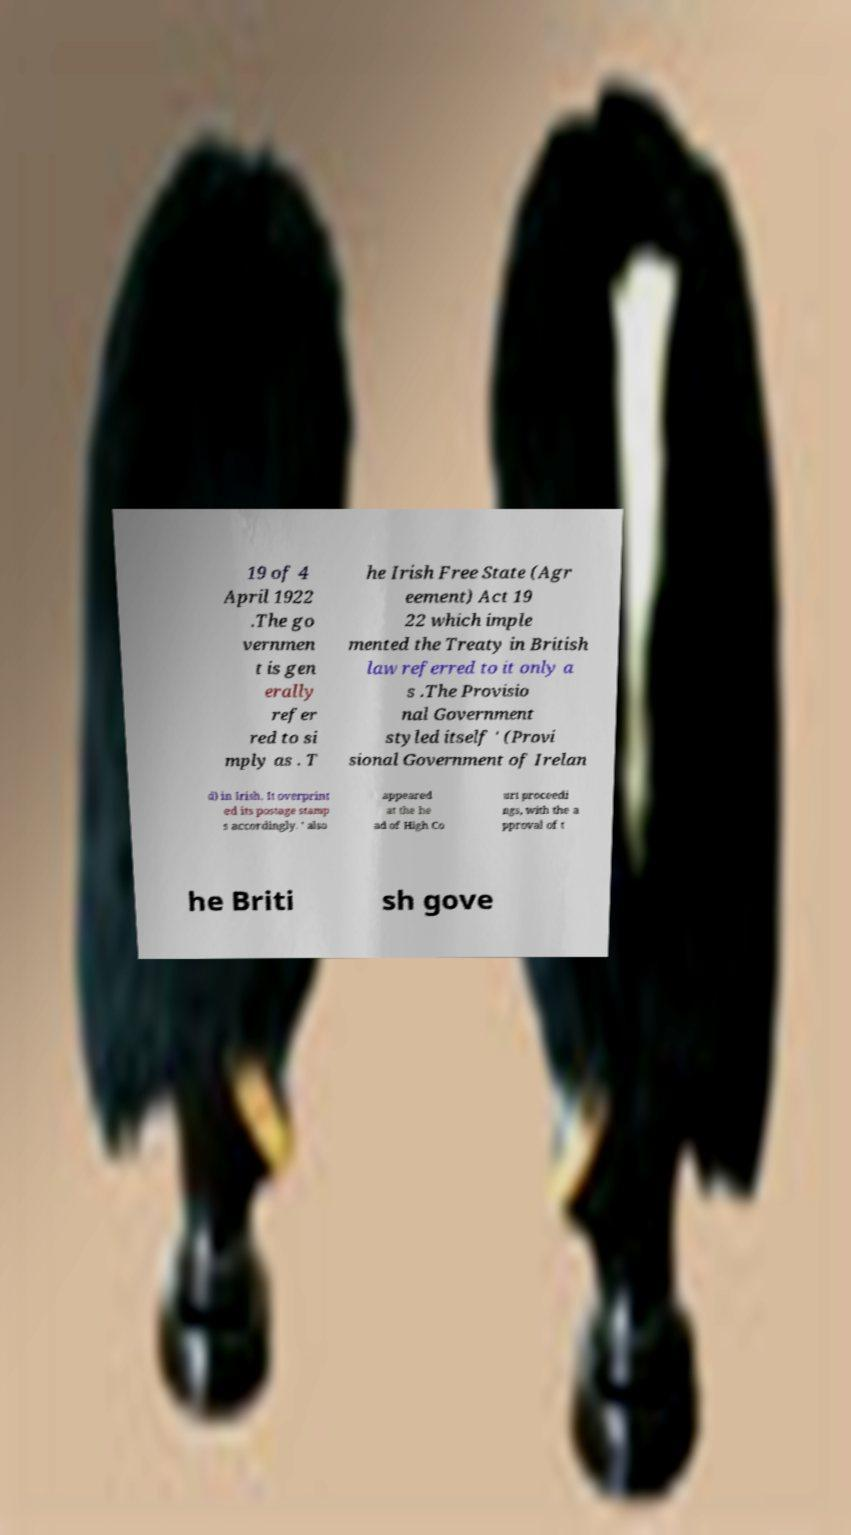Could you assist in decoding the text presented in this image and type it out clearly? 19 of 4 April 1922 .The go vernmen t is gen erally refer red to si mply as . T he Irish Free State (Agr eement) Act 19 22 which imple mented the Treaty in British law referred to it only a s .The Provisio nal Government styled itself ' (Provi sional Government of Irelan d) in Irish. It overprint ed its postage stamp s accordingly. ' also appeared at the he ad of High Co urt proceedi ngs, with the a pproval of t he Briti sh gove 